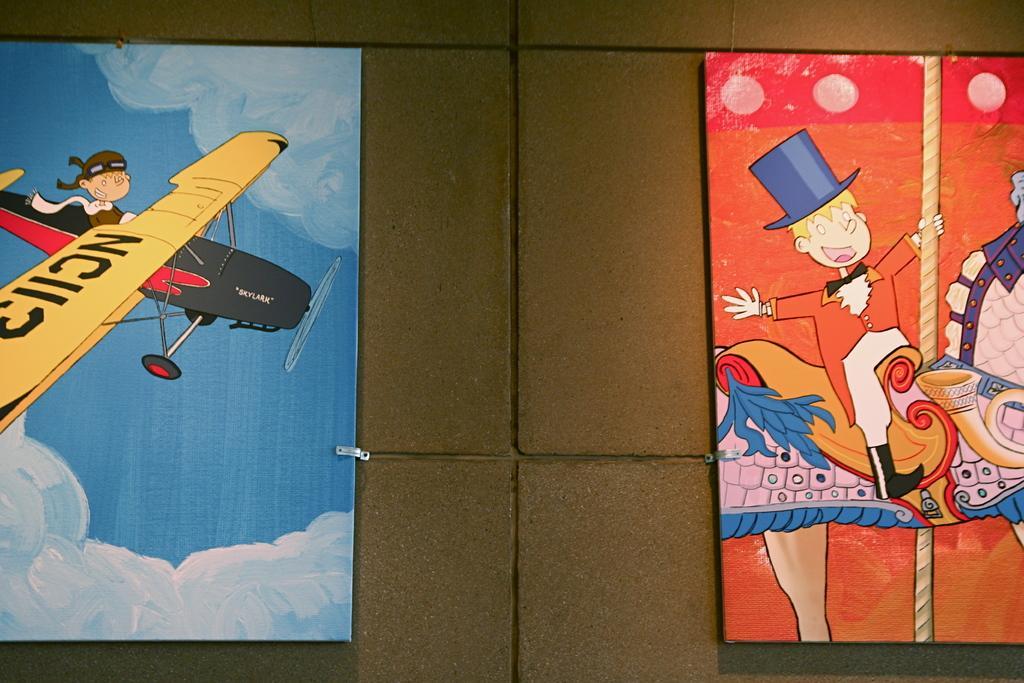How would you summarize this image in a sentence or two? In this picture we can see cartoon boards on the wall. 